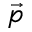<formula> <loc_0><loc_0><loc_500><loc_500>\vec { p }</formula> 